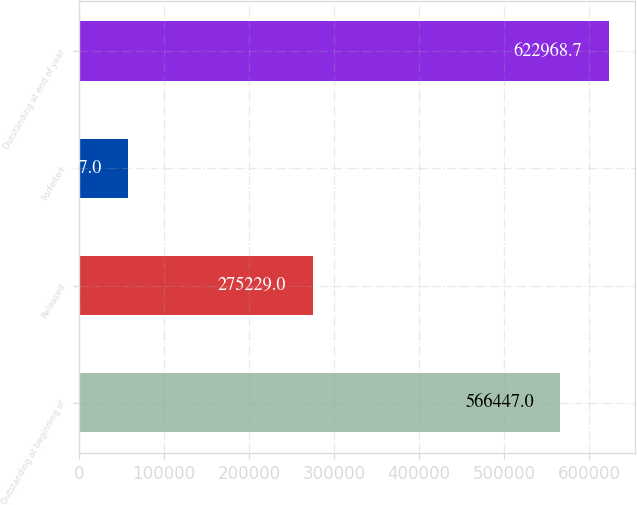Convert chart to OTSL. <chart><loc_0><loc_0><loc_500><loc_500><bar_chart><fcel>Outstanding at beginning of<fcel>Released<fcel>Forfeited<fcel>Outstanding at end of year<nl><fcel>566447<fcel>275229<fcel>57597<fcel>622969<nl></chart> 